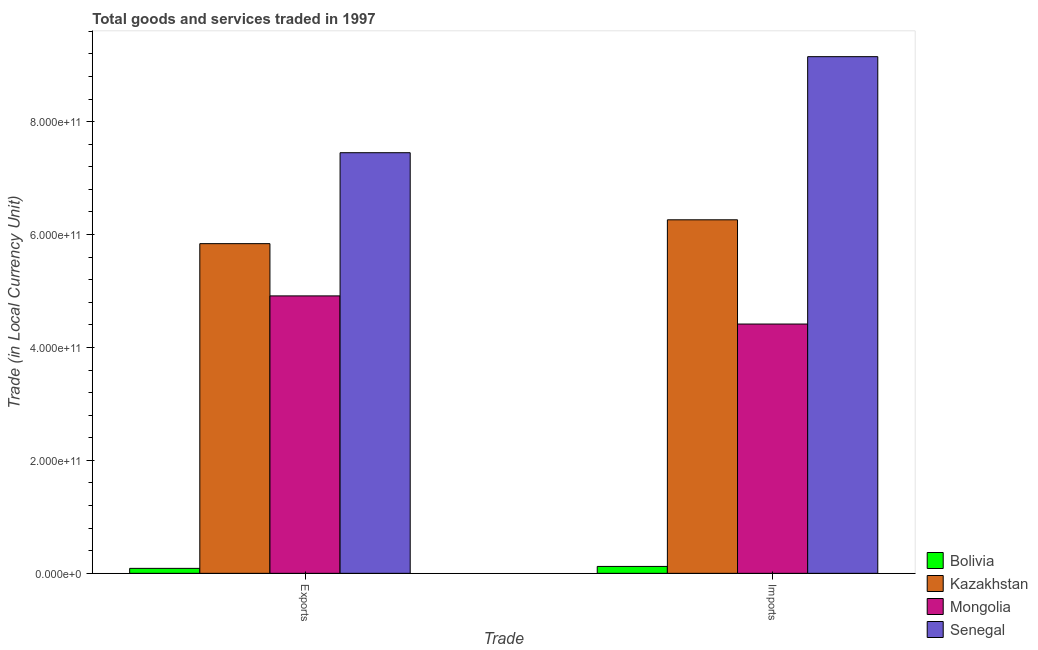How many different coloured bars are there?
Your answer should be compact. 4. Are the number of bars per tick equal to the number of legend labels?
Your answer should be very brief. Yes. How many bars are there on the 2nd tick from the left?
Ensure brevity in your answer.  4. What is the label of the 1st group of bars from the left?
Offer a very short reply. Exports. What is the export of goods and services in Mongolia?
Make the answer very short. 4.91e+11. Across all countries, what is the maximum export of goods and services?
Offer a terse response. 7.45e+11. Across all countries, what is the minimum export of goods and services?
Make the answer very short. 8.79e+09. In which country was the imports of goods and services maximum?
Keep it short and to the point. Senegal. What is the total export of goods and services in the graph?
Offer a very short reply. 1.83e+12. What is the difference between the imports of goods and services in Mongolia and that in Kazakhstan?
Provide a short and direct response. -1.85e+11. What is the difference between the export of goods and services in Kazakhstan and the imports of goods and services in Bolivia?
Provide a short and direct response. 5.72e+11. What is the average export of goods and services per country?
Make the answer very short. 4.57e+11. What is the difference between the export of goods and services and imports of goods and services in Kazakhstan?
Ensure brevity in your answer.  -4.22e+1. In how many countries, is the export of goods and services greater than 760000000000 LCU?
Your response must be concise. 0. What is the ratio of the export of goods and services in Mongolia to that in Bolivia?
Offer a terse response. 55.89. Is the export of goods and services in Mongolia less than that in Senegal?
Offer a terse response. Yes. What does the 1st bar from the left in Exports represents?
Keep it short and to the point. Bolivia. What does the 1st bar from the right in Imports represents?
Offer a very short reply. Senegal. How many bars are there?
Give a very brief answer. 8. Are all the bars in the graph horizontal?
Your response must be concise. No. How many countries are there in the graph?
Provide a succinct answer. 4. What is the difference between two consecutive major ticks on the Y-axis?
Your answer should be compact. 2.00e+11. Does the graph contain any zero values?
Provide a succinct answer. No. Does the graph contain grids?
Make the answer very short. No. How many legend labels are there?
Offer a terse response. 4. What is the title of the graph?
Offer a terse response. Total goods and services traded in 1997. Does "Peru" appear as one of the legend labels in the graph?
Offer a very short reply. No. What is the label or title of the X-axis?
Make the answer very short. Trade. What is the label or title of the Y-axis?
Keep it short and to the point. Trade (in Local Currency Unit). What is the Trade (in Local Currency Unit) of Bolivia in Exports?
Make the answer very short. 8.79e+09. What is the Trade (in Local Currency Unit) of Kazakhstan in Exports?
Make the answer very short. 5.84e+11. What is the Trade (in Local Currency Unit) of Mongolia in Exports?
Your answer should be very brief. 4.91e+11. What is the Trade (in Local Currency Unit) of Senegal in Exports?
Provide a succinct answer. 7.45e+11. What is the Trade (in Local Currency Unit) of Bolivia in Imports?
Give a very brief answer. 1.22e+1. What is the Trade (in Local Currency Unit) in Kazakhstan in Imports?
Your answer should be very brief. 6.26e+11. What is the Trade (in Local Currency Unit) of Mongolia in Imports?
Offer a very short reply. 4.42e+11. What is the Trade (in Local Currency Unit) in Senegal in Imports?
Your answer should be very brief. 9.15e+11. Across all Trade, what is the maximum Trade (in Local Currency Unit) of Bolivia?
Your answer should be compact. 1.22e+1. Across all Trade, what is the maximum Trade (in Local Currency Unit) in Kazakhstan?
Offer a terse response. 6.26e+11. Across all Trade, what is the maximum Trade (in Local Currency Unit) in Mongolia?
Your response must be concise. 4.91e+11. Across all Trade, what is the maximum Trade (in Local Currency Unit) of Senegal?
Offer a terse response. 9.15e+11. Across all Trade, what is the minimum Trade (in Local Currency Unit) in Bolivia?
Make the answer very short. 8.79e+09. Across all Trade, what is the minimum Trade (in Local Currency Unit) in Kazakhstan?
Ensure brevity in your answer.  5.84e+11. Across all Trade, what is the minimum Trade (in Local Currency Unit) of Mongolia?
Your answer should be compact. 4.42e+11. Across all Trade, what is the minimum Trade (in Local Currency Unit) in Senegal?
Your response must be concise. 7.45e+11. What is the total Trade (in Local Currency Unit) of Bolivia in the graph?
Your response must be concise. 2.10e+1. What is the total Trade (in Local Currency Unit) of Kazakhstan in the graph?
Provide a short and direct response. 1.21e+12. What is the total Trade (in Local Currency Unit) of Mongolia in the graph?
Offer a very short reply. 9.33e+11. What is the total Trade (in Local Currency Unit) of Senegal in the graph?
Your answer should be compact. 1.66e+12. What is the difference between the Trade (in Local Currency Unit) of Bolivia in Exports and that in Imports?
Ensure brevity in your answer.  -3.43e+09. What is the difference between the Trade (in Local Currency Unit) in Kazakhstan in Exports and that in Imports?
Make the answer very short. -4.22e+1. What is the difference between the Trade (in Local Currency Unit) in Mongolia in Exports and that in Imports?
Ensure brevity in your answer.  4.98e+1. What is the difference between the Trade (in Local Currency Unit) of Senegal in Exports and that in Imports?
Make the answer very short. -1.70e+11. What is the difference between the Trade (in Local Currency Unit) of Bolivia in Exports and the Trade (in Local Currency Unit) of Kazakhstan in Imports?
Provide a short and direct response. -6.17e+11. What is the difference between the Trade (in Local Currency Unit) in Bolivia in Exports and the Trade (in Local Currency Unit) in Mongolia in Imports?
Make the answer very short. -4.33e+11. What is the difference between the Trade (in Local Currency Unit) of Bolivia in Exports and the Trade (in Local Currency Unit) of Senegal in Imports?
Give a very brief answer. -9.06e+11. What is the difference between the Trade (in Local Currency Unit) in Kazakhstan in Exports and the Trade (in Local Currency Unit) in Mongolia in Imports?
Offer a terse response. 1.42e+11. What is the difference between the Trade (in Local Currency Unit) of Kazakhstan in Exports and the Trade (in Local Currency Unit) of Senegal in Imports?
Offer a terse response. -3.31e+11. What is the difference between the Trade (in Local Currency Unit) in Mongolia in Exports and the Trade (in Local Currency Unit) in Senegal in Imports?
Ensure brevity in your answer.  -4.24e+11. What is the average Trade (in Local Currency Unit) of Bolivia per Trade?
Offer a very short reply. 1.05e+1. What is the average Trade (in Local Currency Unit) of Kazakhstan per Trade?
Your answer should be very brief. 6.05e+11. What is the average Trade (in Local Currency Unit) in Mongolia per Trade?
Provide a short and direct response. 4.66e+11. What is the average Trade (in Local Currency Unit) in Senegal per Trade?
Your response must be concise. 8.30e+11. What is the difference between the Trade (in Local Currency Unit) in Bolivia and Trade (in Local Currency Unit) in Kazakhstan in Exports?
Provide a succinct answer. -5.75e+11. What is the difference between the Trade (in Local Currency Unit) of Bolivia and Trade (in Local Currency Unit) of Mongolia in Exports?
Keep it short and to the point. -4.83e+11. What is the difference between the Trade (in Local Currency Unit) in Bolivia and Trade (in Local Currency Unit) in Senegal in Exports?
Offer a terse response. -7.36e+11. What is the difference between the Trade (in Local Currency Unit) of Kazakhstan and Trade (in Local Currency Unit) of Mongolia in Exports?
Provide a succinct answer. 9.25e+1. What is the difference between the Trade (in Local Currency Unit) of Kazakhstan and Trade (in Local Currency Unit) of Senegal in Exports?
Ensure brevity in your answer.  -1.61e+11. What is the difference between the Trade (in Local Currency Unit) in Mongolia and Trade (in Local Currency Unit) in Senegal in Exports?
Keep it short and to the point. -2.54e+11. What is the difference between the Trade (in Local Currency Unit) in Bolivia and Trade (in Local Currency Unit) in Kazakhstan in Imports?
Keep it short and to the point. -6.14e+11. What is the difference between the Trade (in Local Currency Unit) of Bolivia and Trade (in Local Currency Unit) of Mongolia in Imports?
Offer a very short reply. -4.29e+11. What is the difference between the Trade (in Local Currency Unit) of Bolivia and Trade (in Local Currency Unit) of Senegal in Imports?
Your answer should be compact. -9.03e+11. What is the difference between the Trade (in Local Currency Unit) in Kazakhstan and Trade (in Local Currency Unit) in Mongolia in Imports?
Provide a short and direct response. 1.85e+11. What is the difference between the Trade (in Local Currency Unit) of Kazakhstan and Trade (in Local Currency Unit) of Senegal in Imports?
Offer a terse response. -2.89e+11. What is the difference between the Trade (in Local Currency Unit) in Mongolia and Trade (in Local Currency Unit) in Senegal in Imports?
Offer a terse response. -4.74e+11. What is the ratio of the Trade (in Local Currency Unit) in Bolivia in Exports to that in Imports?
Make the answer very short. 0.72. What is the ratio of the Trade (in Local Currency Unit) of Kazakhstan in Exports to that in Imports?
Make the answer very short. 0.93. What is the ratio of the Trade (in Local Currency Unit) in Mongolia in Exports to that in Imports?
Give a very brief answer. 1.11. What is the ratio of the Trade (in Local Currency Unit) of Senegal in Exports to that in Imports?
Provide a succinct answer. 0.81. What is the difference between the highest and the second highest Trade (in Local Currency Unit) of Bolivia?
Give a very brief answer. 3.43e+09. What is the difference between the highest and the second highest Trade (in Local Currency Unit) in Kazakhstan?
Provide a short and direct response. 4.22e+1. What is the difference between the highest and the second highest Trade (in Local Currency Unit) of Mongolia?
Provide a short and direct response. 4.98e+1. What is the difference between the highest and the second highest Trade (in Local Currency Unit) of Senegal?
Your answer should be very brief. 1.70e+11. What is the difference between the highest and the lowest Trade (in Local Currency Unit) of Bolivia?
Give a very brief answer. 3.43e+09. What is the difference between the highest and the lowest Trade (in Local Currency Unit) in Kazakhstan?
Offer a terse response. 4.22e+1. What is the difference between the highest and the lowest Trade (in Local Currency Unit) in Mongolia?
Offer a very short reply. 4.98e+1. What is the difference between the highest and the lowest Trade (in Local Currency Unit) of Senegal?
Offer a very short reply. 1.70e+11. 